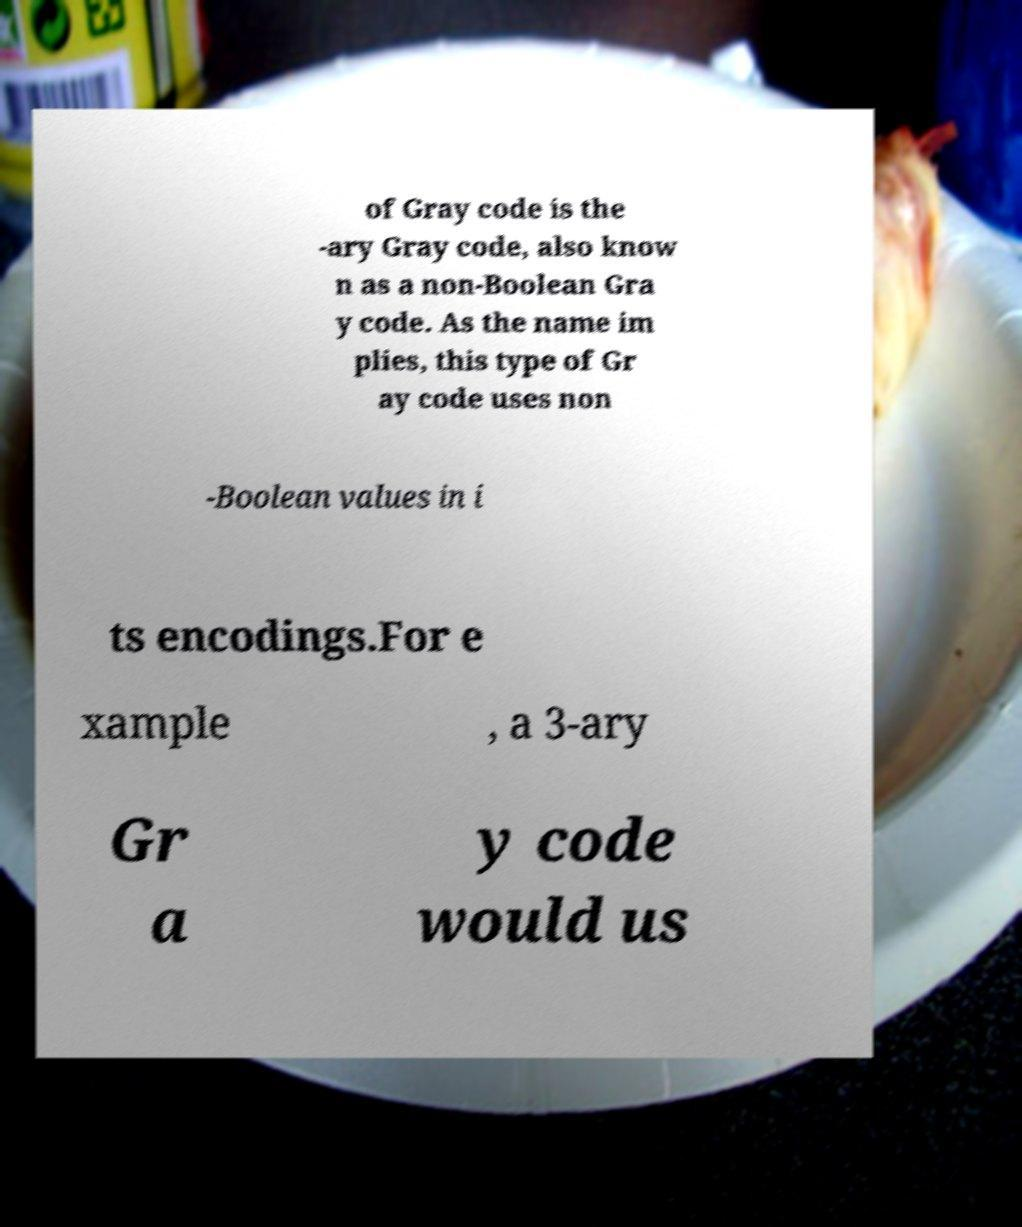Could you extract and type out the text from this image? of Gray code is the -ary Gray code, also know n as a non-Boolean Gra y code. As the name im plies, this type of Gr ay code uses non -Boolean values in i ts encodings.For e xample , a 3-ary Gr a y code would us 